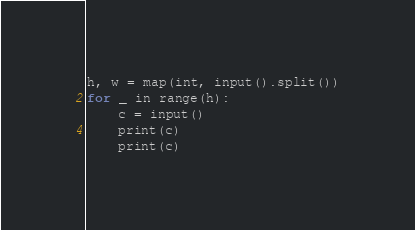<code> <loc_0><loc_0><loc_500><loc_500><_Python_>h, w = map(int, input().split())
for _ in range(h):
    c = input()
    print(c)
    print(c)</code> 